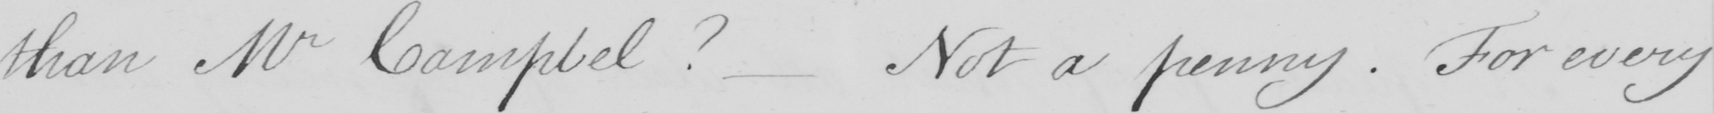Please provide the text content of this handwritten line. than Mr Campbel ?  Not a penny . For every 